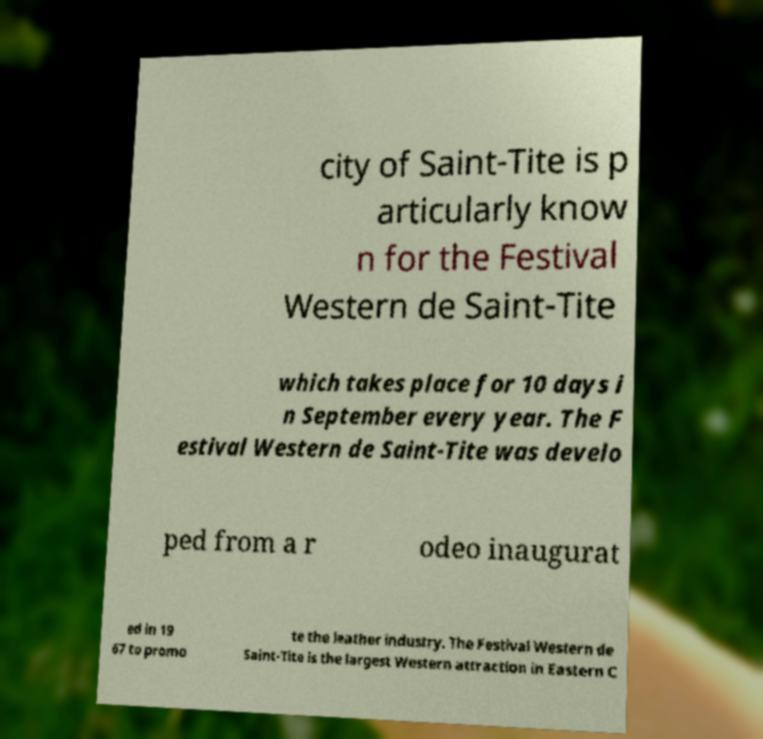Could you assist in decoding the text presented in this image and type it out clearly? city of Saint-Tite is p articularly know n for the Festival Western de Saint-Tite which takes place for 10 days i n September every year. The F estival Western de Saint-Tite was develo ped from a r odeo inaugurat ed in 19 67 to promo te the leather industry. The Festival Western de Saint-Tite is the largest Western attraction in Eastern C 